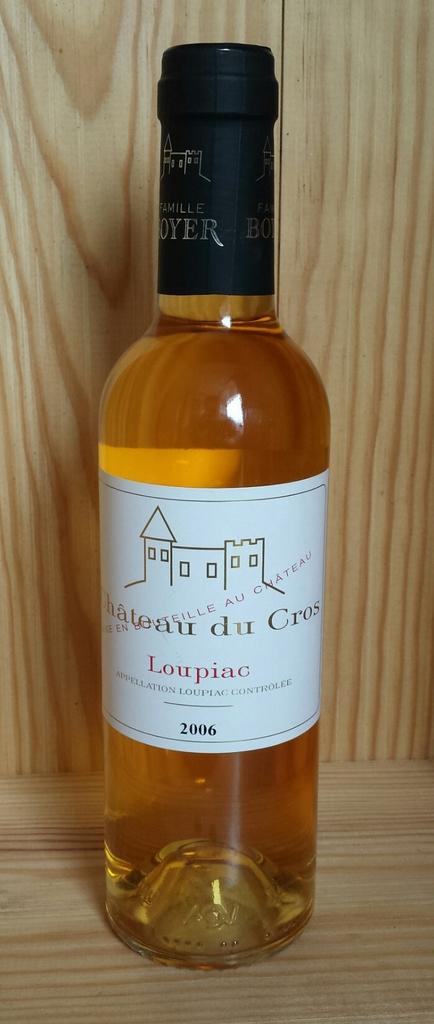What year was this made in?
Your answer should be compact. 2006. 